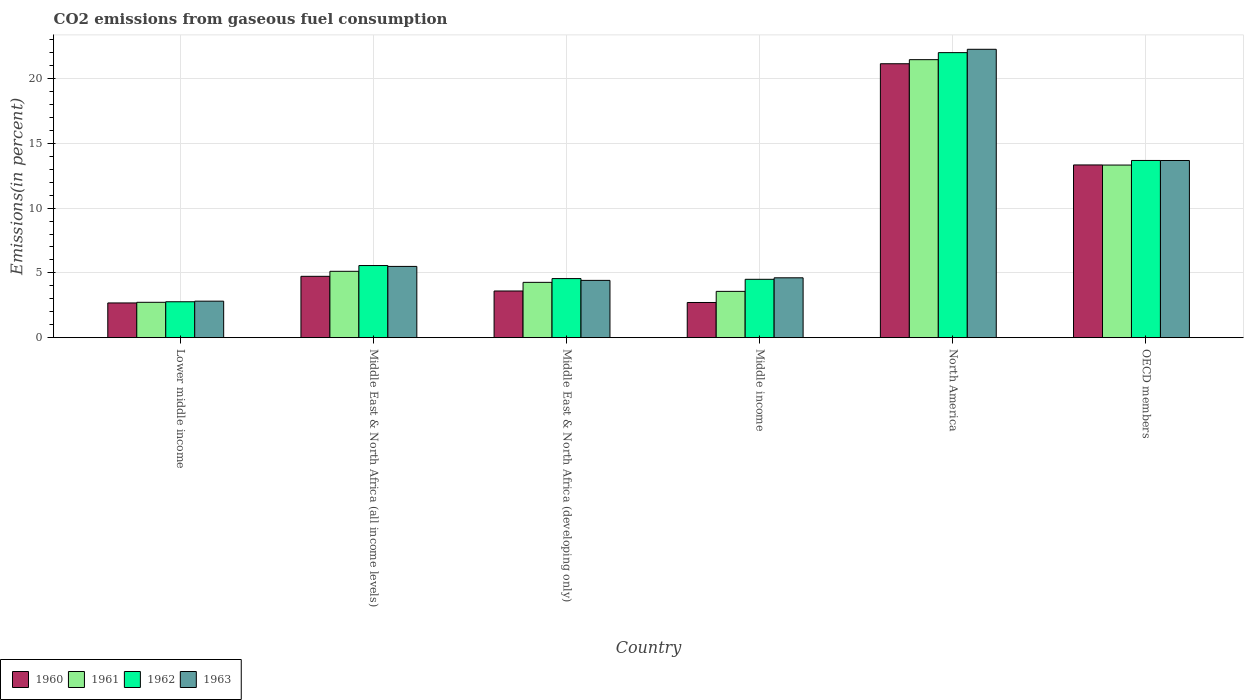How many different coloured bars are there?
Offer a terse response. 4. Are the number of bars per tick equal to the number of legend labels?
Your response must be concise. Yes. How many bars are there on the 6th tick from the left?
Your response must be concise. 4. How many bars are there on the 3rd tick from the right?
Ensure brevity in your answer.  4. What is the label of the 2nd group of bars from the left?
Provide a short and direct response. Middle East & North Africa (all income levels). What is the total CO2 emitted in 1960 in Middle East & North Africa (developing only)?
Keep it short and to the point. 3.6. Across all countries, what is the maximum total CO2 emitted in 1962?
Offer a terse response. 22. Across all countries, what is the minimum total CO2 emitted in 1963?
Keep it short and to the point. 2.82. In which country was the total CO2 emitted in 1960 minimum?
Make the answer very short. Lower middle income. What is the total total CO2 emitted in 1962 in the graph?
Keep it short and to the point. 53.09. What is the difference between the total CO2 emitted in 1963 in Lower middle income and that in OECD members?
Your answer should be compact. -10.86. What is the difference between the total CO2 emitted in 1963 in Middle East & North Africa (all income levels) and the total CO2 emitted in 1961 in Lower middle income?
Offer a terse response. 2.77. What is the average total CO2 emitted in 1961 per country?
Your answer should be very brief. 8.41. What is the difference between the total CO2 emitted of/in 1962 and total CO2 emitted of/in 1963 in OECD members?
Keep it short and to the point. 0. In how many countries, is the total CO2 emitted in 1963 greater than 16 %?
Your response must be concise. 1. What is the ratio of the total CO2 emitted in 1961 in North America to that in OECD members?
Provide a succinct answer. 1.61. Is the total CO2 emitted in 1963 in Lower middle income less than that in Middle East & North Africa (all income levels)?
Keep it short and to the point. Yes. Is the difference between the total CO2 emitted in 1962 in Middle East & North Africa (all income levels) and Middle income greater than the difference between the total CO2 emitted in 1963 in Middle East & North Africa (all income levels) and Middle income?
Your answer should be very brief. Yes. What is the difference between the highest and the second highest total CO2 emitted in 1962?
Give a very brief answer. -8.11. What is the difference between the highest and the lowest total CO2 emitted in 1962?
Your answer should be very brief. 19.23. In how many countries, is the total CO2 emitted in 1962 greater than the average total CO2 emitted in 1962 taken over all countries?
Provide a short and direct response. 2. Is it the case that in every country, the sum of the total CO2 emitted in 1962 and total CO2 emitted in 1961 is greater than the sum of total CO2 emitted in 1960 and total CO2 emitted in 1963?
Ensure brevity in your answer.  No. How many bars are there?
Offer a terse response. 24. Are all the bars in the graph horizontal?
Your answer should be very brief. No. How many countries are there in the graph?
Provide a succinct answer. 6. Does the graph contain grids?
Make the answer very short. Yes. What is the title of the graph?
Give a very brief answer. CO2 emissions from gaseous fuel consumption. Does "1976" appear as one of the legend labels in the graph?
Offer a terse response. No. What is the label or title of the Y-axis?
Provide a succinct answer. Emissions(in percent). What is the Emissions(in percent) in 1960 in Lower middle income?
Your answer should be compact. 2.68. What is the Emissions(in percent) of 1961 in Lower middle income?
Provide a short and direct response. 2.73. What is the Emissions(in percent) in 1962 in Lower middle income?
Offer a terse response. 2.77. What is the Emissions(in percent) of 1963 in Lower middle income?
Keep it short and to the point. 2.82. What is the Emissions(in percent) in 1960 in Middle East & North Africa (all income levels)?
Offer a terse response. 4.74. What is the Emissions(in percent) in 1961 in Middle East & North Africa (all income levels)?
Provide a succinct answer. 5.12. What is the Emissions(in percent) in 1962 in Middle East & North Africa (all income levels)?
Keep it short and to the point. 5.57. What is the Emissions(in percent) of 1963 in Middle East & North Africa (all income levels)?
Offer a terse response. 5.5. What is the Emissions(in percent) of 1960 in Middle East & North Africa (developing only)?
Ensure brevity in your answer.  3.6. What is the Emissions(in percent) in 1961 in Middle East & North Africa (developing only)?
Keep it short and to the point. 4.27. What is the Emissions(in percent) of 1962 in Middle East & North Africa (developing only)?
Offer a terse response. 4.56. What is the Emissions(in percent) of 1963 in Middle East & North Africa (developing only)?
Provide a succinct answer. 4.42. What is the Emissions(in percent) in 1960 in Middle income?
Your response must be concise. 2.72. What is the Emissions(in percent) in 1961 in Middle income?
Provide a succinct answer. 3.57. What is the Emissions(in percent) in 1962 in Middle income?
Your answer should be compact. 4.5. What is the Emissions(in percent) of 1963 in Middle income?
Offer a very short reply. 4.62. What is the Emissions(in percent) of 1960 in North America?
Keep it short and to the point. 21.15. What is the Emissions(in percent) in 1961 in North America?
Ensure brevity in your answer.  21.46. What is the Emissions(in percent) of 1962 in North America?
Provide a succinct answer. 22. What is the Emissions(in percent) in 1963 in North America?
Keep it short and to the point. 22.26. What is the Emissions(in percent) of 1960 in OECD members?
Your answer should be very brief. 13.33. What is the Emissions(in percent) of 1961 in OECD members?
Your answer should be compact. 13.33. What is the Emissions(in percent) of 1962 in OECD members?
Keep it short and to the point. 13.68. What is the Emissions(in percent) in 1963 in OECD members?
Offer a very short reply. 13.68. Across all countries, what is the maximum Emissions(in percent) of 1960?
Offer a very short reply. 21.15. Across all countries, what is the maximum Emissions(in percent) in 1961?
Ensure brevity in your answer.  21.46. Across all countries, what is the maximum Emissions(in percent) of 1962?
Offer a terse response. 22. Across all countries, what is the maximum Emissions(in percent) in 1963?
Make the answer very short. 22.26. Across all countries, what is the minimum Emissions(in percent) in 1960?
Keep it short and to the point. 2.68. Across all countries, what is the minimum Emissions(in percent) of 1961?
Ensure brevity in your answer.  2.73. Across all countries, what is the minimum Emissions(in percent) in 1962?
Ensure brevity in your answer.  2.77. Across all countries, what is the minimum Emissions(in percent) in 1963?
Provide a succinct answer. 2.82. What is the total Emissions(in percent) of 1960 in the graph?
Keep it short and to the point. 48.22. What is the total Emissions(in percent) in 1961 in the graph?
Offer a very short reply. 50.48. What is the total Emissions(in percent) in 1962 in the graph?
Make the answer very short. 53.09. What is the total Emissions(in percent) in 1963 in the graph?
Give a very brief answer. 53.3. What is the difference between the Emissions(in percent) of 1960 in Lower middle income and that in Middle East & North Africa (all income levels)?
Provide a short and direct response. -2.06. What is the difference between the Emissions(in percent) in 1961 in Lower middle income and that in Middle East & North Africa (all income levels)?
Keep it short and to the point. -2.39. What is the difference between the Emissions(in percent) of 1962 in Lower middle income and that in Middle East & North Africa (all income levels)?
Ensure brevity in your answer.  -2.8. What is the difference between the Emissions(in percent) of 1963 in Lower middle income and that in Middle East & North Africa (all income levels)?
Make the answer very short. -2.68. What is the difference between the Emissions(in percent) in 1960 in Lower middle income and that in Middle East & North Africa (developing only)?
Provide a short and direct response. -0.92. What is the difference between the Emissions(in percent) in 1961 in Lower middle income and that in Middle East & North Africa (developing only)?
Give a very brief answer. -1.54. What is the difference between the Emissions(in percent) in 1962 in Lower middle income and that in Middle East & North Africa (developing only)?
Give a very brief answer. -1.79. What is the difference between the Emissions(in percent) in 1963 in Lower middle income and that in Middle East & North Africa (developing only)?
Your answer should be very brief. -1.6. What is the difference between the Emissions(in percent) in 1960 in Lower middle income and that in Middle income?
Ensure brevity in your answer.  -0.03. What is the difference between the Emissions(in percent) of 1961 in Lower middle income and that in Middle income?
Provide a short and direct response. -0.84. What is the difference between the Emissions(in percent) in 1962 in Lower middle income and that in Middle income?
Offer a terse response. -1.73. What is the difference between the Emissions(in percent) in 1963 in Lower middle income and that in Middle income?
Provide a short and direct response. -1.8. What is the difference between the Emissions(in percent) of 1960 in Lower middle income and that in North America?
Provide a succinct answer. -18.47. What is the difference between the Emissions(in percent) of 1961 in Lower middle income and that in North America?
Ensure brevity in your answer.  -18.73. What is the difference between the Emissions(in percent) in 1962 in Lower middle income and that in North America?
Offer a terse response. -19.23. What is the difference between the Emissions(in percent) in 1963 in Lower middle income and that in North America?
Your answer should be very brief. -19.44. What is the difference between the Emissions(in percent) of 1960 in Lower middle income and that in OECD members?
Keep it short and to the point. -10.65. What is the difference between the Emissions(in percent) of 1961 in Lower middle income and that in OECD members?
Make the answer very short. -10.6. What is the difference between the Emissions(in percent) in 1962 in Lower middle income and that in OECD members?
Your answer should be compact. -10.91. What is the difference between the Emissions(in percent) in 1963 in Lower middle income and that in OECD members?
Provide a short and direct response. -10.86. What is the difference between the Emissions(in percent) in 1960 in Middle East & North Africa (all income levels) and that in Middle East & North Africa (developing only)?
Your answer should be very brief. 1.13. What is the difference between the Emissions(in percent) of 1961 in Middle East & North Africa (all income levels) and that in Middle East & North Africa (developing only)?
Give a very brief answer. 0.85. What is the difference between the Emissions(in percent) in 1962 in Middle East & North Africa (all income levels) and that in Middle East & North Africa (developing only)?
Make the answer very short. 1.01. What is the difference between the Emissions(in percent) of 1963 in Middle East & North Africa (all income levels) and that in Middle East & North Africa (developing only)?
Provide a short and direct response. 1.08. What is the difference between the Emissions(in percent) of 1960 in Middle East & North Africa (all income levels) and that in Middle income?
Ensure brevity in your answer.  2.02. What is the difference between the Emissions(in percent) of 1961 in Middle East & North Africa (all income levels) and that in Middle income?
Provide a succinct answer. 1.55. What is the difference between the Emissions(in percent) in 1962 in Middle East & North Africa (all income levels) and that in Middle income?
Your response must be concise. 1.06. What is the difference between the Emissions(in percent) of 1963 in Middle East & North Africa (all income levels) and that in Middle income?
Make the answer very short. 0.88. What is the difference between the Emissions(in percent) of 1960 in Middle East & North Africa (all income levels) and that in North America?
Provide a short and direct response. -16.41. What is the difference between the Emissions(in percent) in 1961 in Middle East & North Africa (all income levels) and that in North America?
Your answer should be very brief. -16.34. What is the difference between the Emissions(in percent) in 1962 in Middle East & North Africa (all income levels) and that in North America?
Make the answer very short. -16.44. What is the difference between the Emissions(in percent) in 1963 in Middle East & North Africa (all income levels) and that in North America?
Keep it short and to the point. -16.76. What is the difference between the Emissions(in percent) in 1960 in Middle East & North Africa (all income levels) and that in OECD members?
Your answer should be compact. -8.6. What is the difference between the Emissions(in percent) of 1961 in Middle East & North Africa (all income levels) and that in OECD members?
Provide a succinct answer. -8.2. What is the difference between the Emissions(in percent) of 1962 in Middle East & North Africa (all income levels) and that in OECD members?
Your answer should be compact. -8.11. What is the difference between the Emissions(in percent) of 1963 in Middle East & North Africa (all income levels) and that in OECD members?
Provide a succinct answer. -8.18. What is the difference between the Emissions(in percent) of 1960 in Middle East & North Africa (developing only) and that in Middle income?
Offer a terse response. 0.89. What is the difference between the Emissions(in percent) of 1961 in Middle East & North Africa (developing only) and that in Middle income?
Give a very brief answer. 0.7. What is the difference between the Emissions(in percent) in 1962 in Middle East & North Africa (developing only) and that in Middle income?
Provide a short and direct response. 0.06. What is the difference between the Emissions(in percent) of 1963 in Middle East & North Africa (developing only) and that in Middle income?
Provide a succinct answer. -0.2. What is the difference between the Emissions(in percent) of 1960 in Middle East & North Africa (developing only) and that in North America?
Keep it short and to the point. -17.54. What is the difference between the Emissions(in percent) of 1961 in Middle East & North Africa (developing only) and that in North America?
Provide a succinct answer. -17.19. What is the difference between the Emissions(in percent) in 1962 in Middle East & North Africa (developing only) and that in North America?
Provide a succinct answer. -17.44. What is the difference between the Emissions(in percent) of 1963 in Middle East & North Africa (developing only) and that in North America?
Give a very brief answer. -17.84. What is the difference between the Emissions(in percent) of 1960 in Middle East & North Africa (developing only) and that in OECD members?
Provide a succinct answer. -9.73. What is the difference between the Emissions(in percent) in 1961 in Middle East & North Africa (developing only) and that in OECD members?
Give a very brief answer. -9.06. What is the difference between the Emissions(in percent) in 1962 in Middle East & North Africa (developing only) and that in OECD members?
Your response must be concise. -9.12. What is the difference between the Emissions(in percent) of 1963 in Middle East & North Africa (developing only) and that in OECD members?
Make the answer very short. -9.25. What is the difference between the Emissions(in percent) in 1960 in Middle income and that in North America?
Ensure brevity in your answer.  -18.43. What is the difference between the Emissions(in percent) of 1961 in Middle income and that in North America?
Provide a short and direct response. -17.89. What is the difference between the Emissions(in percent) in 1962 in Middle income and that in North America?
Give a very brief answer. -17.5. What is the difference between the Emissions(in percent) of 1963 in Middle income and that in North America?
Make the answer very short. -17.64. What is the difference between the Emissions(in percent) in 1960 in Middle income and that in OECD members?
Your response must be concise. -10.62. What is the difference between the Emissions(in percent) in 1961 in Middle income and that in OECD members?
Your answer should be very brief. -9.75. What is the difference between the Emissions(in percent) in 1962 in Middle income and that in OECD members?
Keep it short and to the point. -9.17. What is the difference between the Emissions(in percent) of 1963 in Middle income and that in OECD members?
Offer a very short reply. -9.06. What is the difference between the Emissions(in percent) of 1960 in North America and that in OECD members?
Offer a very short reply. 7.81. What is the difference between the Emissions(in percent) of 1961 in North America and that in OECD members?
Keep it short and to the point. 8.14. What is the difference between the Emissions(in percent) in 1962 in North America and that in OECD members?
Your answer should be compact. 8.32. What is the difference between the Emissions(in percent) in 1963 in North America and that in OECD members?
Your answer should be very brief. 8.58. What is the difference between the Emissions(in percent) in 1960 in Lower middle income and the Emissions(in percent) in 1961 in Middle East & North Africa (all income levels)?
Offer a very short reply. -2.44. What is the difference between the Emissions(in percent) in 1960 in Lower middle income and the Emissions(in percent) in 1962 in Middle East & North Africa (all income levels)?
Your answer should be compact. -2.89. What is the difference between the Emissions(in percent) of 1960 in Lower middle income and the Emissions(in percent) of 1963 in Middle East & North Africa (all income levels)?
Offer a terse response. -2.82. What is the difference between the Emissions(in percent) in 1961 in Lower middle income and the Emissions(in percent) in 1962 in Middle East & North Africa (all income levels)?
Your answer should be very brief. -2.84. What is the difference between the Emissions(in percent) of 1961 in Lower middle income and the Emissions(in percent) of 1963 in Middle East & North Africa (all income levels)?
Give a very brief answer. -2.77. What is the difference between the Emissions(in percent) in 1962 in Lower middle income and the Emissions(in percent) in 1963 in Middle East & North Africa (all income levels)?
Keep it short and to the point. -2.73. What is the difference between the Emissions(in percent) in 1960 in Lower middle income and the Emissions(in percent) in 1961 in Middle East & North Africa (developing only)?
Provide a succinct answer. -1.59. What is the difference between the Emissions(in percent) of 1960 in Lower middle income and the Emissions(in percent) of 1962 in Middle East & North Africa (developing only)?
Give a very brief answer. -1.88. What is the difference between the Emissions(in percent) of 1960 in Lower middle income and the Emissions(in percent) of 1963 in Middle East & North Africa (developing only)?
Make the answer very short. -1.74. What is the difference between the Emissions(in percent) of 1961 in Lower middle income and the Emissions(in percent) of 1962 in Middle East & North Africa (developing only)?
Ensure brevity in your answer.  -1.83. What is the difference between the Emissions(in percent) in 1961 in Lower middle income and the Emissions(in percent) in 1963 in Middle East & North Africa (developing only)?
Your answer should be compact. -1.69. What is the difference between the Emissions(in percent) of 1962 in Lower middle income and the Emissions(in percent) of 1963 in Middle East & North Africa (developing only)?
Ensure brevity in your answer.  -1.65. What is the difference between the Emissions(in percent) of 1960 in Lower middle income and the Emissions(in percent) of 1961 in Middle income?
Your answer should be compact. -0.89. What is the difference between the Emissions(in percent) of 1960 in Lower middle income and the Emissions(in percent) of 1962 in Middle income?
Provide a short and direct response. -1.82. What is the difference between the Emissions(in percent) of 1960 in Lower middle income and the Emissions(in percent) of 1963 in Middle income?
Your answer should be compact. -1.94. What is the difference between the Emissions(in percent) of 1961 in Lower middle income and the Emissions(in percent) of 1962 in Middle income?
Offer a very short reply. -1.78. What is the difference between the Emissions(in percent) in 1961 in Lower middle income and the Emissions(in percent) in 1963 in Middle income?
Provide a short and direct response. -1.89. What is the difference between the Emissions(in percent) of 1962 in Lower middle income and the Emissions(in percent) of 1963 in Middle income?
Ensure brevity in your answer.  -1.85. What is the difference between the Emissions(in percent) of 1960 in Lower middle income and the Emissions(in percent) of 1961 in North America?
Ensure brevity in your answer.  -18.78. What is the difference between the Emissions(in percent) of 1960 in Lower middle income and the Emissions(in percent) of 1962 in North America?
Your answer should be compact. -19.32. What is the difference between the Emissions(in percent) in 1960 in Lower middle income and the Emissions(in percent) in 1963 in North America?
Your response must be concise. -19.58. What is the difference between the Emissions(in percent) of 1961 in Lower middle income and the Emissions(in percent) of 1962 in North America?
Your answer should be compact. -19.27. What is the difference between the Emissions(in percent) in 1961 in Lower middle income and the Emissions(in percent) in 1963 in North America?
Ensure brevity in your answer.  -19.53. What is the difference between the Emissions(in percent) in 1962 in Lower middle income and the Emissions(in percent) in 1963 in North America?
Your answer should be very brief. -19.49. What is the difference between the Emissions(in percent) of 1960 in Lower middle income and the Emissions(in percent) of 1961 in OECD members?
Offer a terse response. -10.64. What is the difference between the Emissions(in percent) of 1960 in Lower middle income and the Emissions(in percent) of 1962 in OECD members?
Make the answer very short. -11. What is the difference between the Emissions(in percent) of 1960 in Lower middle income and the Emissions(in percent) of 1963 in OECD members?
Ensure brevity in your answer.  -11. What is the difference between the Emissions(in percent) in 1961 in Lower middle income and the Emissions(in percent) in 1962 in OECD members?
Offer a very short reply. -10.95. What is the difference between the Emissions(in percent) in 1961 in Lower middle income and the Emissions(in percent) in 1963 in OECD members?
Offer a very short reply. -10.95. What is the difference between the Emissions(in percent) of 1962 in Lower middle income and the Emissions(in percent) of 1963 in OECD members?
Your response must be concise. -10.91. What is the difference between the Emissions(in percent) in 1960 in Middle East & North Africa (all income levels) and the Emissions(in percent) in 1961 in Middle East & North Africa (developing only)?
Give a very brief answer. 0.47. What is the difference between the Emissions(in percent) in 1960 in Middle East & North Africa (all income levels) and the Emissions(in percent) in 1962 in Middle East & North Africa (developing only)?
Make the answer very short. 0.18. What is the difference between the Emissions(in percent) of 1960 in Middle East & North Africa (all income levels) and the Emissions(in percent) of 1963 in Middle East & North Africa (developing only)?
Your answer should be very brief. 0.31. What is the difference between the Emissions(in percent) of 1961 in Middle East & North Africa (all income levels) and the Emissions(in percent) of 1962 in Middle East & North Africa (developing only)?
Your answer should be very brief. 0.56. What is the difference between the Emissions(in percent) in 1961 in Middle East & North Africa (all income levels) and the Emissions(in percent) in 1963 in Middle East & North Africa (developing only)?
Offer a very short reply. 0.7. What is the difference between the Emissions(in percent) in 1962 in Middle East & North Africa (all income levels) and the Emissions(in percent) in 1963 in Middle East & North Africa (developing only)?
Provide a short and direct response. 1.15. What is the difference between the Emissions(in percent) in 1960 in Middle East & North Africa (all income levels) and the Emissions(in percent) in 1961 in Middle income?
Offer a terse response. 1.16. What is the difference between the Emissions(in percent) of 1960 in Middle East & North Africa (all income levels) and the Emissions(in percent) of 1962 in Middle income?
Your answer should be compact. 0.23. What is the difference between the Emissions(in percent) in 1960 in Middle East & North Africa (all income levels) and the Emissions(in percent) in 1963 in Middle income?
Your response must be concise. 0.12. What is the difference between the Emissions(in percent) in 1961 in Middle East & North Africa (all income levels) and the Emissions(in percent) in 1962 in Middle income?
Provide a succinct answer. 0.62. What is the difference between the Emissions(in percent) in 1961 in Middle East & North Africa (all income levels) and the Emissions(in percent) in 1963 in Middle income?
Offer a very short reply. 0.5. What is the difference between the Emissions(in percent) of 1962 in Middle East & North Africa (all income levels) and the Emissions(in percent) of 1963 in Middle income?
Offer a terse response. 0.95. What is the difference between the Emissions(in percent) of 1960 in Middle East & North Africa (all income levels) and the Emissions(in percent) of 1961 in North America?
Make the answer very short. -16.73. What is the difference between the Emissions(in percent) in 1960 in Middle East & North Africa (all income levels) and the Emissions(in percent) in 1962 in North America?
Ensure brevity in your answer.  -17.27. What is the difference between the Emissions(in percent) in 1960 in Middle East & North Africa (all income levels) and the Emissions(in percent) in 1963 in North America?
Make the answer very short. -17.53. What is the difference between the Emissions(in percent) of 1961 in Middle East & North Africa (all income levels) and the Emissions(in percent) of 1962 in North America?
Offer a very short reply. -16.88. What is the difference between the Emissions(in percent) in 1961 in Middle East & North Africa (all income levels) and the Emissions(in percent) in 1963 in North America?
Make the answer very short. -17.14. What is the difference between the Emissions(in percent) of 1962 in Middle East & North Africa (all income levels) and the Emissions(in percent) of 1963 in North America?
Your answer should be compact. -16.69. What is the difference between the Emissions(in percent) of 1960 in Middle East & North Africa (all income levels) and the Emissions(in percent) of 1961 in OECD members?
Your answer should be compact. -8.59. What is the difference between the Emissions(in percent) of 1960 in Middle East & North Africa (all income levels) and the Emissions(in percent) of 1962 in OECD members?
Ensure brevity in your answer.  -8.94. What is the difference between the Emissions(in percent) in 1960 in Middle East & North Africa (all income levels) and the Emissions(in percent) in 1963 in OECD members?
Your response must be concise. -8.94. What is the difference between the Emissions(in percent) in 1961 in Middle East & North Africa (all income levels) and the Emissions(in percent) in 1962 in OECD members?
Your response must be concise. -8.56. What is the difference between the Emissions(in percent) in 1961 in Middle East & North Africa (all income levels) and the Emissions(in percent) in 1963 in OECD members?
Ensure brevity in your answer.  -8.55. What is the difference between the Emissions(in percent) of 1962 in Middle East & North Africa (all income levels) and the Emissions(in percent) of 1963 in OECD members?
Offer a terse response. -8.11. What is the difference between the Emissions(in percent) in 1960 in Middle East & North Africa (developing only) and the Emissions(in percent) in 1961 in Middle income?
Your response must be concise. 0.03. What is the difference between the Emissions(in percent) in 1960 in Middle East & North Africa (developing only) and the Emissions(in percent) in 1962 in Middle income?
Give a very brief answer. -0.9. What is the difference between the Emissions(in percent) in 1960 in Middle East & North Africa (developing only) and the Emissions(in percent) in 1963 in Middle income?
Offer a terse response. -1.02. What is the difference between the Emissions(in percent) in 1961 in Middle East & North Africa (developing only) and the Emissions(in percent) in 1962 in Middle income?
Give a very brief answer. -0.24. What is the difference between the Emissions(in percent) of 1961 in Middle East & North Africa (developing only) and the Emissions(in percent) of 1963 in Middle income?
Provide a succinct answer. -0.35. What is the difference between the Emissions(in percent) in 1962 in Middle East & North Africa (developing only) and the Emissions(in percent) in 1963 in Middle income?
Your answer should be compact. -0.06. What is the difference between the Emissions(in percent) of 1960 in Middle East & North Africa (developing only) and the Emissions(in percent) of 1961 in North America?
Ensure brevity in your answer.  -17.86. What is the difference between the Emissions(in percent) of 1960 in Middle East & North Africa (developing only) and the Emissions(in percent) of 1962 in North America?
Your response must be concise. -18.4. What is the difference between the Emissions(in percent) in 1960 in Middle East & North Africa (developing only) and the Emissions(in percent) in 1963 in North America?
Your response must be concise. -18.66. What is the difference between the Emissions(in percent) in 1961 in Middle East & North Africa (developing only) and the Emissions(in percent) in 1962 in North America?
Your answer should be very brief. -17.73. What is the difference between the Emissions(in percent) of 1961 in Middle East & North Africa (developing only) and the Emissions(in percent) of 1963 in North America?
Keep it short and to the point. -17.99. What is the difference between the Emissions(in percent) in 1962 in Middle East & North Africa (developing only) and the Emissions(in percent) in 1963 in North America?
Keep it short and to the point. -17.7. What is the difference between the Emissions(in percent) of 1960 in Middle East & North Africa (developing only) and the Emissions(in percent) of 1961 in OECD members?
Keep it short and to the point. -9.72. What is the difference between the Emissions(in percent) in 1960 in Middle East & North Africa (developing only) and the Emissions(in percent) in 1962 in OECD members?
Make the answer very short. -10.08. What is the difference between the Emissions(in percent) in 1960 in Middle East & North Africa (developing only) and the Emissions(in percent) in 1963 in OECD members?
Offer a very short reply. -10.07. What is the difference between the Emissions(in percent) of 1961 in Middle East & North Africa (developing only) and the Emissions(in percent) of 1962 in OECD members?
Make the answer very short. -9.41. What is the difference between the Emissions(in percent) of 1961 in Middle East & North Africa (developing only) and the Emissions(in percent) of 1963 in OECD members?
Your answer should be very brief. -9.41. What is the difference between the Emissions(in percent) of 1962 in Middle East & North Africa (developing only) and the Emissions(in percent) of 1963 in OECD members?
Your answer should be very brief. -9.12. What is the difference between the Emissions(in percent) of 1960 in Middle income and the Emissions(in percent) of 1961 in North America?
Ensure brevity in your answer.  -18.75. What is the difference between the Emissions(in percent) of 1960 in Middle income and the Emissions(in percent) of 1962 in North America?
Make the answer very short. -19.29. What is the difference between the Emissions(in percent) in 1960 in Middle income and the Emissions(in percent) in 1963 in North America?
Ensure brevity in your answer.  -19.55. What is the difference between the Emissions(in percent) in 1961 in Middle income and the Emissions(in percent) in 1962 in North America?
Make the answer very short. -18.43. What is the difference between the Emissions(in percent) of 1961 in Middle income and the Emissions(in percent) of 1963 in North America?
Make the answer very short. -18.69. What is the difference between the Emissions(in percent) of 1962 in Middle income and the Emissions(in percent) of 1963 in North America?
Provide a succinct answer. -17.76. What is the difference between the Emissions(in percent) in 1960 in Middle income and the Emissions(in percent) in 1961 in OECD members?
Make the answer very short. -10.61. What is the difference between the Emissions(in percent) in 1960 in Middle income and the Emissions(in percent) in 1962 in OECD members?
Give a very brief answer. -10.96. What is the difference between the Emissions(in percent) of 1960 in Middle income and the Emissions(in percent) of 1963 in OECD members?
Your answer should be very brief. -10.96. What is the difference between the Emissions(in percent) of 1961 in Middle income and the Emissions(in percent) of 1962 in OECD members?
Offer a terse response. -10.11. What is the difference between the Emissions(in percent) in 1961 in Middle income and the Emissions(in percent) in 1963 in OECD members?
Ensure brevity in your answer.  -10.1. What is the difference between the Emissions(in percent) in 1962 in Middle income and the Emissions(in percent) in 1963 in OECD members?
Provide a succinct answer. -9.17. What is the difference between the Emissions(in percent) in 1960 in North America and the Emissions(in percent) in 1961 in OECD members?
Your response must be concise. 7.82. What is the difference between the Emissions(in percent) in 1960 in North America and the Emissions(in percent) in 1962 in OECD members?
Ensure brevity in your answer.  7.47. What is the difference between the Emissions(in percent) of 1960 in North America and the Emissions(in percent) of 1963 in OECD members?
Your answer should be very brief. 7.47. What is the difference between the Emissions(in percent) in 1961 in North America and the Emissions(in percent) in 1962 in OECD members?
Provide a short and direct response. 7.78. What is the difference between the Emissions(in percent) of 1961 in North America and the Emissions(in percent) of 1963 in OECD members?
Your response must be concise. 7.78. What is the difference between the Emissions(in percent) in 1962 in North America and the Emissions(in percent) in 1963 in OECD members?
Offer a very short reply. 8.33. What is the average Emissions(in percent) in 1960 per country?
Offer a terse response. 8.04. What is the average Emissions(in percent) in 1961 per country?
Your answer should be very brief. 8.41. What is the average Emissions(in percent) in 1962 per country?
Offer a terse response. 8.85. What is the average Emissions(in percent) in 1963 per country?
Provide a succinct answer. 8.88. What is the difference between the Emissions(in percent) in 1960 and Emissions(in percent) in 1961 in Lower middle income?
Give a very brief answer. -0.05. What is the difference between the Emissions(in percent) in 1960 and Emissions(in percent) in 1962 in Lower middle income?
Offer a very short reply. -0.09. What is the difference between the Emissions(in percent) of 1960 and Emissions(in percent) of 1963 in Lower middle income?
Your answer should be very brief. -0.14. What is the difference between the Emissions(in percent) of 1961 and Emissions(in percent) of 1962 in Lower middle income?
Your response must be concise. -0.04. What is the difference between the Emissions(in percent) in 1961 and Emissions(in percent) in 1963 in Lower middle income?
Offer a terse response. -0.09. What is the difference between the Emissions(in percent) of 1962 and Emissions(in percent) of 1963 in Lower middle income?
Offer a terse response. -0.05. What is the difference between the Emissions(in percent) of 1960 and Emissions(in percent) of 1961 in Middle East & North Africa (all income levels)?
Provide a short and direct response. -0.39. What is the difference between the Emissions(in percent) in 1960 and Emissions(in percent) in 1962 in Middle East & North Africa (all income levels)?
Give a very brief answer. -0.83. What is the difference between the Emissions(in percent) in 1960 and Emissions(in percent) in 1963 in Middle East & North Africa (all income levels)?
Offer a terse response. -0.76. What is the difference between the Emissions(in percent) of 1961 and Emissions(in percent) of 1962 in Middle East & North Africa (all income levels)?
Keep it short and to the point. -0.45. What is the difference between the Emissions(in percent) in 1961 and Emissions(in percent) in 1963 in Middle East & North Africa (all income levels)?
Offer a terse response. -0.38. What is the difference between the Emissions(in percent) in 1962 and Emissions(in percent) in 1963 in Middle East & North Africa (all income levels)?
Keep it short and to the point. 0.07. What is the difference between the Emissions(in percent) in 1960 and Emissions(in percent) in 1961 in Middle East & North Africa (developing only)?
Provide a succinct answer. -0.67. What is the difference between the Emissions(in percent) in 1960 and Emissions(in percent) in 1962 in Middle East & North Africa (developing only)?
Your answer should be very brief. -0.96. What is the difference between the Emissions(in percent) of 1960 and Emissions(in percent) of 1963 in Middle East & North Africa (developing only)?
Keep it short and to the point. -0.82. What is the difference between the Emissions(in percent) of 1961 and Emissions(in percent) of 1962 in Middle East & North Africa (developing only)?
Provide a short and direct response. -0.29. What is the difference between the Emissions(in percent) in 1961 and Emissions(in percent) in 1963 in Middle East & North Africa (developing only)?
Ensure brevity in your answer.  -0.15. What is the difference between the Emissions(in percent) in 1962 and Emissions(in percent) in 1963 in Middle East & North Africa (developing only)?
Provide a succinct answer. 0.14. What is the difference between the Emissions(in percent) of 1960 and Emissions(in percent) of 1961 in Middle income?
Provide a succinct answer. -0.86. What is the difference between the Emissions(in percent) of 1960 and Emissions(in percent) of 1962 in Middle income?
Give a very brief answer. -1.79. What is the difference between the Emissions(in percent) of 1960 and Emissions(in percent) of 1963 in Middle income?
Offer a terse response. -1.91. What is the difference between the Emissions(in percent) in 1961 and Emissions(in percent) in 1962 in Middle income?
Keep it short and to the point. -0.93. What is the difference between the Emissions(in percent) of 1961 and Emissions(in percent) of 1963 in Middle income?
Make the answer very short. -1.05. What is the difference between the Emissions(in percent) in 1962 and Emissions(in percent) in 1963 in Middle income?
Your answer should be very brief. -0.12. What is the difference between the Emissions(in percent) of 1960 and Emissions(in percent) of 1961 in North America?
Offer a terse response. -0.32. What is the difference between the Emissions(in percent) of 1960 and Emissions(in percent) of 1962 in North America?
Provide a succinct answer. -0.86. What is the difference between the Emissions(in percent) of 1960 and Emissions(in percent) of 1963 in North America?
Ensure brevity in your answer.  -1.12. What is the difference between the Emissions(in percent) in 1961 and Emissions(in percent) in 1962 in North America?
Give a very brief answer. -0.54. What is the difference between the Emissions(in percent) in 1961 and Emissions(in percent) in 1963 in North America?
Give a very brief answer. -0.8. What is the difference between the Emissions(in percent) of 1962 and Emissions(in percent) of 1963 in North America?
Your answer should be very brief. -0.26. What is the difference between the Emissions(in percent) in 1960 and Emissions(in percent) in 1961 in OECD members?
Your answer should be very brief. 0.01. What is the difference between the Emissions(in percent) in 1960 and Emissions(in percent) in 1962 in OECD members?
Your answer should be compact. -0.35. What is the difference between the Emissions(in percent) of 1960 and Emissions(in percent) of 1963 in OECD members?
Your answer should be compact. -0.34. What is the difference between the Emissions(in percent) of 1961 and Emissions(in percent) of 1962 in OECD members?
Keep it short and to the point. -0.35. What is the difference between the Emissions(in percent) in 1961 and Emissions(in percent) in 1963 in OECD members?
Your response must be concise. -0.35. What is the difference between the Emissions(in percent) in 1962 and Emissions(in percent) in 1963 in OECD members?
Provide a short and direct response. 0. What is the ratio of the Emissions(in percent) in 1960 in Lower middle income to that in Middle East & North Africa (all income levels)?
Your answer should be compact. 0.57. What is the ratio of the Emissions(in percent) in 1961 in Lower middle income to that in Middle East & North Africa (all income levels)?
Offer a very short reply. 0.53. What is the ratio of the Emissions(in percent) of 1962 in Lower middle income to that in Middle East & North Africa (all income levels)?
Ensure brevity in your answer.  0.5. What is the ratio of the Emissions(in percent) in 1963 in Lower middle income to that in Middle East & North Africa (all income levels)?
Give a very brief answer. 0.51. What is the ratio of the Emissions(in percent) of 1960 in Lower middle income to that in Middle East & North Africa (developing only)?
Your response must be concise. 0.74. What is the ratio of the Emissions(in percent) of 1961 in Lower middle income to that in Middle East & North Africa (developing only)?
Your answer should be very brief. 0.64. What is the ratio of the Emissions(in percent) of 1962 in Lower middle income to that in Middle East & North Africa (developing only)?
Provide a succinct answer. 0.61. What is the ratio of the Emissions(in percent) of 1963 in Lower middle income to that in Middle East & North Africa (developing only)?
Provide a short and direct response. 0.64. What is the ratio of the Emissions(in percent) of 1960 in Lower middle income to that in Middle income?
Provide a short and direct response. 0.99. What is the ratio of the Emissions(in percent) of 1961 in Lower middle income to that in Middle income?
Ensure brevity in your answer.  0.76. What is the ratio of the Emissions(in percent) of 1962 in Lower middle income to that in Middle income?
Keep it short and to the point. 0.62. What is the ratio of the Emissions(in percent) of 1963 in Lower middle income to that in Middle income?
Offer a terse response. 0.61. What is the ratio of the Emissions(in percent) of 1960 in Lower middle income to that in North America?
Your answer should be very brief. 0.13. What is the ratio of the Emissions(in percent) in 1961 in Lower middle income to that in North America?
Provide a short and direct response. 0.13. What is the ratio of the Emissions(in percent) of 1962 in Lower middle income to that in North America?
Your answer should be very brief. 0.13. What is the ratio of the Emissions(in percent) in 1963 in Lower middle income to that in North America?
Provide a short and direct response. 0.13. What is the ratio of the Emissions(in percent) of 1960 in Lower middle income to that in OECD members?
Offer a terse response. 0.2. What is the ratio of the Emissions(in percent) in 1961 in Lower middle income to that in OECD members?
Provide a succinct answer. 0.2. What is the ratio of the Emissions(in percent) of 1962 in Lower middle income to that in OECD members?
Your response must be concise. 0.2. What is the ratio of the Emissions(in percent) of 1963 in Lower middle income to that in OECD members?
Keep it short and to the point. 0.21. What is the ratio of the Emissions(in percent) of 1960 in Middle East & North Africa (all income levels) to that in Middle East & North Africa (developing only)?
Make the answer very short. 1.31. What is the ratio of the Emissions(in percent) of 1961 in Middle East & North Africa (all income levels) to that in Middle East & North Africa (developing only)?
Your response must be concise. 1.2. What is the ratio of the Emissions(in percent) in 1962 in Middle East & North Africa (all income levels) to that in Middle East & North Africa (developing only)?
Keep it short and to the point. 1.22. What is the ratio of the Emissions(in percent) in 1963 in Middle East & North Africa (all income levels) to that in Middle East & North Africa (developing only)?
Keep it short and to the point. 1.24. What is the ratio of the Emissions(in percent) in 1960 in Middle East & North Africa (all income levels) to that in Middle income?
Ensure brevity in your answer.  1.74. What is the ratio of the Emissions(in percent) in 1961 in Middle East & North Africa (all income levels) to that in Middle income?
Provide a succinct answer. 1.43. What is the ratio of the Emissions(in percent) in 1962 in Middle East & North Africa (all income levels) to that in Middle income?
Offer a terse response. 1.24. What is the ratio of the Emissions(in percent) of 1963 in Middle East & North Africa (all income levels) to that in Middle income?
Your answer should be very brief. 1.19. What is the ratio of the Emissions(in percent) in 1960 in Middle East & North Africa (all income levels) to that in North America?
Offer a very short reply. 0.22. What is the ratio of the Emissions(in percent) in 1961 in Middle East & North Africa (all income levels) to that in North America?
Offer a very short reply. 0.24. What is the ratio of the Emissions(in percent) in 1962 in Middle East & North Africa (all income levels) to that in North America?
Offer a terse response. 0.25. What is the ratio of the Emissions(in percent) in 1963 in Middle East & North Africa (all income levels) to that in North America?
Keep it short and to the point. 0.25. What is the ratio of the Emissions(in percent) of 1960 in Middle East & North Africa (all income levels) to that in OECD members?
Offer a terse response. 0.36. What is the ratio of the Emissions(in percent) of 1961 in Middle East & North Africa (all income levels) to that in OECD members?
Your answer should be compact. 0.38. What is the ratio of the Emissions(in percent) in 1962 in Middle East & North Africa (all income levels) to that in OECD members?
Provide a short and direct response. 0.41. What is the ratio of the Emissions(in percent) of 1963 in Middle East & North Africa (all income levels) to that in OECD members?
Provide a short and direct response. 0.4. What is the ratio of the Emissions(in percent) in 1960 in Middle East & North Africa (developing only) to that in Middle income?
Ensure brevity in your answer.  1.33. What is the ratio of the Emissions(in percent) in 1961 in Middle East & North Africa (developing only) to that in Middle income?
Give a very brief answer. 1.19. What is the ratio of the Emissions(in percent) in 1962 in Middle East & North Africa (developing only) to that in Middle income?
Offer a very short reply. 1.01. What is the ratio of the Emissions(in percent) of 1963 in Middle East & North Africa (developing only) to that in Middle income?
Keep it short and to the point. 0.96. What is the ratio of the Emissions(in percent) in 1960 in Middle East & North Africa (developing only) to that in North America?
Offer a terse response. 0.17. What is the ratio of the Emissions(in percent) in 1961 in Middle East & North Africa (developing only) to that in North America?
Ensure brevity in your answer.  0.2. What is the ratio of the Emissions(in percent) of 1962 in Middle East & North Africa (developing only) to that in North America?
Give a very brief answer. 0.21. What is the ratio of the Emissions(in percent) in 1963 in Middle East & North Africa (developing only) to that in North America?
Your answer should be very brief. 0.2. What is the ratio of the Emissions(in percent) of 1960 in Middle East & North Africa (developing only) to that in OECD members?
Make the answer very short. 0.27. What is the ratio of the Emissions(in percent) in 1961 in Middle East & North Africa (developing only) to that in OECD members?
Provide a short and direct response. 0.32. What is the ratio of the Emissions(in percent) in 1962 in Middle East & North Africa (developing only) to that in OECD members?
Your response must be concise. 0.33. What is the ratio of the Emissions(in percent) in 1963 in Middle East & North Africa (developing only) to that in OECD members?
Give a very brief answer. 0.32. What is the ratio of the Emissions(in percent) in 1960 in Middle income to that in North America?
Your answer should be compact. 0.13. What is the ratio of the Emissions(in percent) in 1961 in Middle income to that in North America?
Provide a short and direct response. 0.17. What is the ratio of the Emissions(in percent) in 1962 in Middle income to that in North America?
Give a very brief answer. 0.2. What is the ratio of the Emissions(in percent) of 1963 in Middle income to that in North America?
Your answer should be very brief. 0.21. What is the ratio of the Emissions(in percent) in 1960 in Middle income to that in OECD members?
Keep it short and to the point. 0.2. What is the ratio of the Emissions(in percent) in 1961 in Middle income to that in OECD members?
Your answer should be compact. 0.27. What is the ratio of the Emissions(in percent) of 1962 in Middle income to that in OECD members?
Give a very brief answer. 0.33. What is the ratio of the Emissions(in percent) in 1963 in Middle income to that in OECD members?
Your answer should be very brief. 0.34. What is the ratio of the Emissions(in percent) of 1960 in North America to that in OECD members?
Your answer should be very brief. 1.59. What is the ratio of the Emissions(in percent) in 1961 in North America to that in OECD members?
Keep it short and to the point. 1.61. What is the ratio of the Emissions(in percent) in 1962 in North America to that in OECD members?
Make the answer very short. 1.61. What is the ratio of the Emissions(in percent) in 1963 in North America to that in OECD members?
Ensure brevity in your answer.  1.63. What is the difference between the highest and the second highest Emissions(in percent) of 1960?
Keep it short and to the point. 7.81. What is the difference between the highest and the second highest Emissions(in percent) in 1961?
Make the answer very short. 8.14. What is the difference between the highest and the second highest Emissions(in percent) of 1962?
Your answer should be compact. 8.32. What is the difference between the highest and the second highest Emissions(in percent) in 1963?
Provide a short and direct response. 8.58. What is the difference between the highest and the lowest Emissions(in percent) of 1960?
Keep it short and to the point. 18.47. What is the difference between the highest and the lowest Emissions(in percent) of 1961?
Your answer should be very brief. 18.73. What is the difference between the highest and the lowest Emissions(in percent) in 1962?
Keep it short and to the point. 19.23. What is the difference between the highest and the lowest Emissions(in percent) of 1963?
Provide a short and direct response. 19.44. 